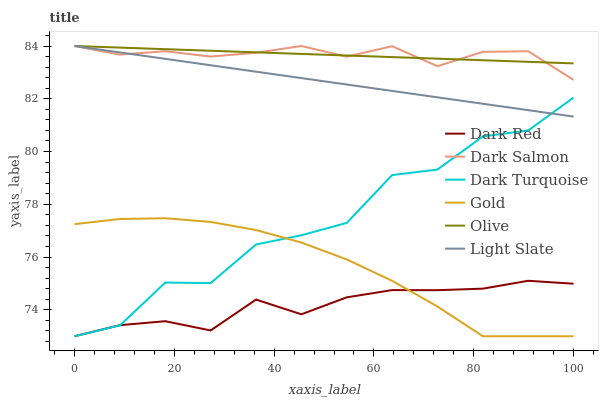Does Dark Red have the minimum area under the curve?
Answer yes or no. Yes. Does Dark Salmon have the maximum area under the curve?
Answer yes or no. Yes. Does Light Slate have the minimum area under the curve?
Answer yes or no. No. Does Light Slate have the maximum area under the curve?
Answer yes or no. No. Is Olive the smoothest?
Answer yes or no. Yes. Is Dark Turquoise the roughest?
Answer yes or no. Yes. Is Light Slate the smoothest?
Answer yes or no. No. Is Light Slate the roughest?
Answer yes or no. No. Does Light Slate have the lowest value?
Answer yes or no. No. Does Olive have the highest value?
Answer yes or no. Yes. Does Dark Red have the highest value?
Answer yes or no. No. Is Gold less than Light Slate?
Answer yes or no. Yes. Is Dark Salmon greater than Dark Turquoise?
Answer yes or no. Yes. Does Dark Red intersect Gold?
Answer yes or no. Yes. Is Dark Red less than Gold?
Answer yes or no. No. Is Dark Red greater than Gold?
Answer yes or no. No. Does Gold intersect Light Slate?
Answer yes or no. No. 